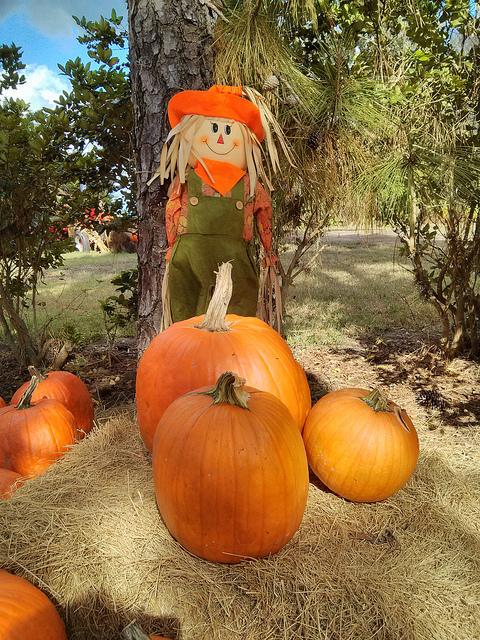What color are the pumpkins?
Concise answer only. Orange. What season is this?
Quick response, please. Fall. What kind of decoration is behind the pumpkin?
Quick response, please. Scarecrow. 